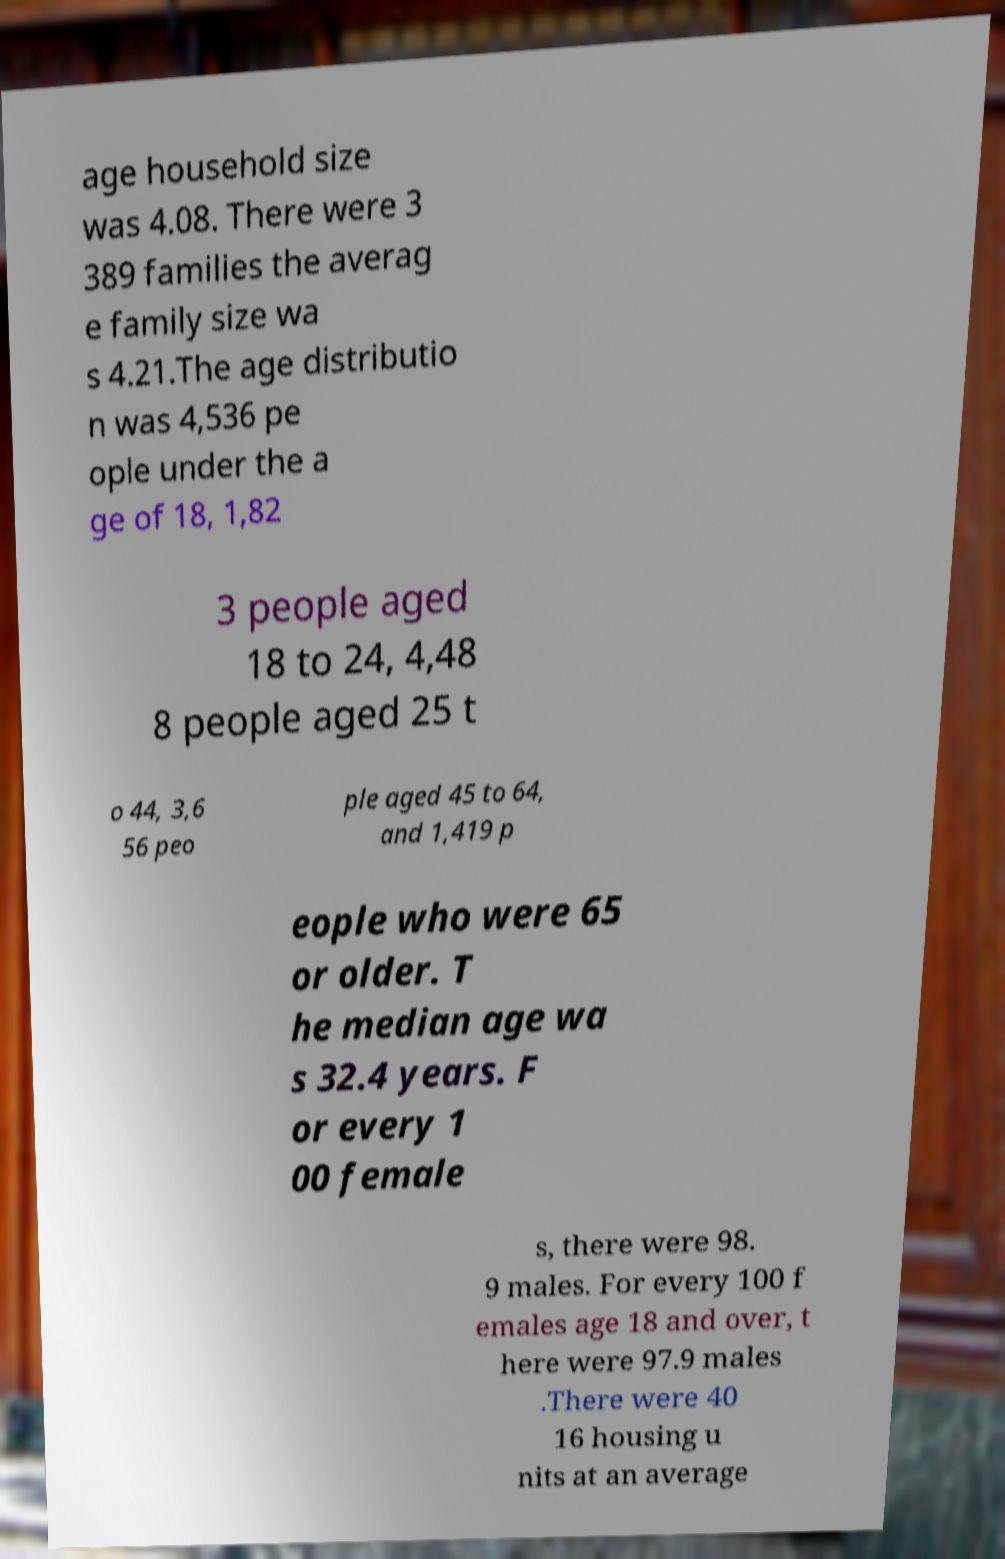Please identify and transcribe the text found in this image. age household size was 4.08. There were 3 389 families the averag e family size wa s 4.21.The age distributio n was 4,536 pe ople under the a ge of 18, 1,82 3 people aged 18 to 24, 4,48 8 people aged 25 t o 44, 3,6 56 peo ple aged 45 to 64, and 1,419 p eople who were 65 or older. T he median age wa s 32.4 years. F or every 1 00 female s, there were 98. 9 males. For every 100 f emales age 18 and over, t here were 97.9 males .There were 40 16 housing u nits at an average 